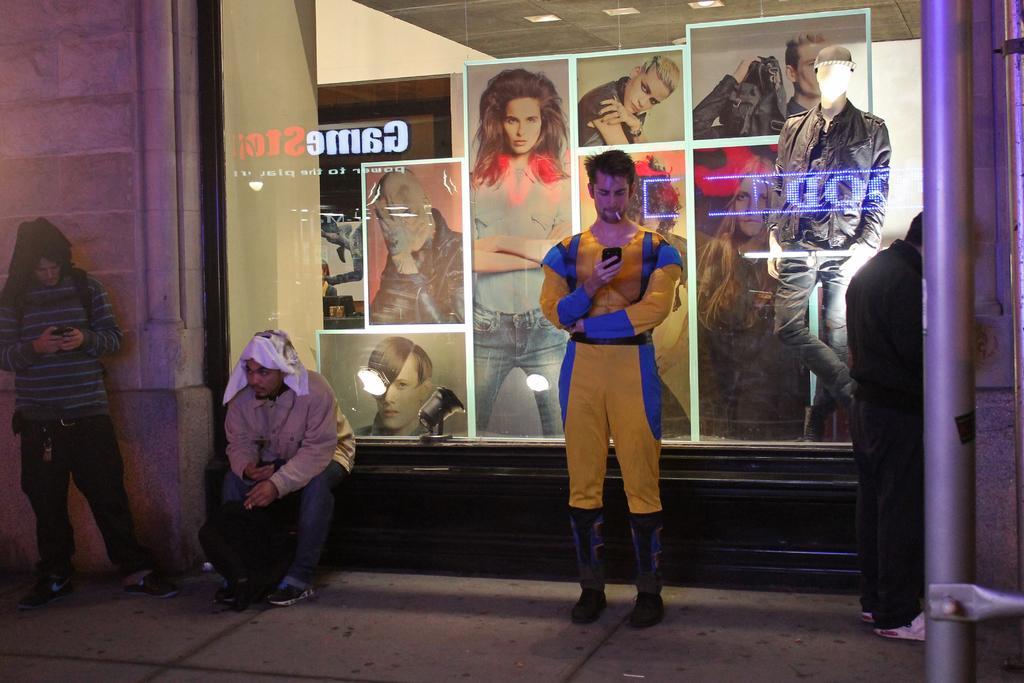In one or two sentences, can you explain what this image depicts? In this image we can see group of persons standing on the ground. In the background, we can see a mannequin with clothes, group of photos and some lights. In the foreground we can see some poles. 